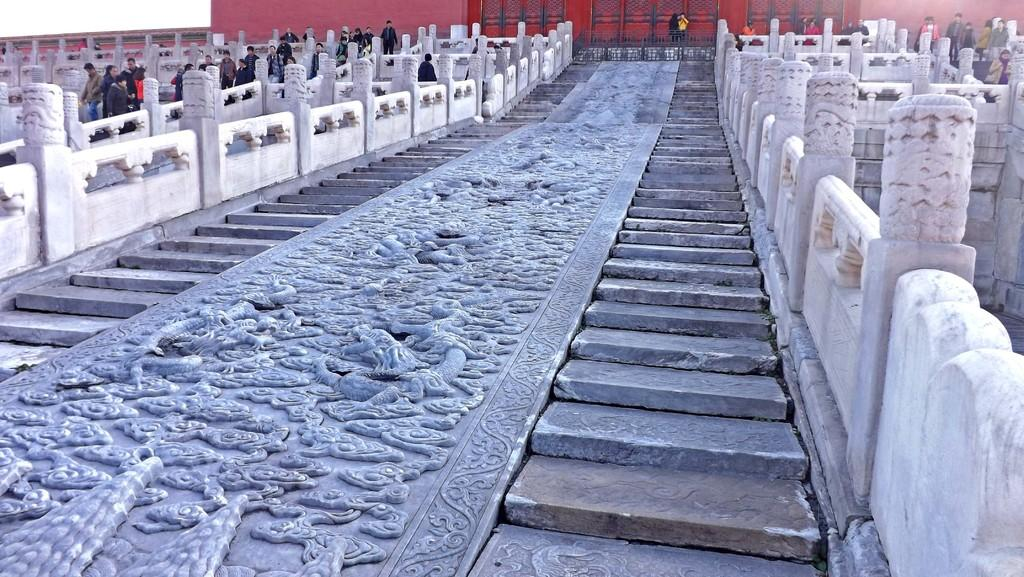What type of architectural feature can be seen in the image? There are stairs in the image. What is located on the floor in the image? There are sculptures on the floor. Can you describe the people in the image? There is a group of people in the image. What other architectural features can be seen in the image? There are sculpted pillars in the image. What type of material is used for the grilles in the image? There are iron grilles in the image. What type of hat is the pipe wearing in the image? There is no pipe or hat present in the image. How many knees are visible in the image? The provided facts do not mention any knees, so it is impossible to determine how many are visible in the image. 